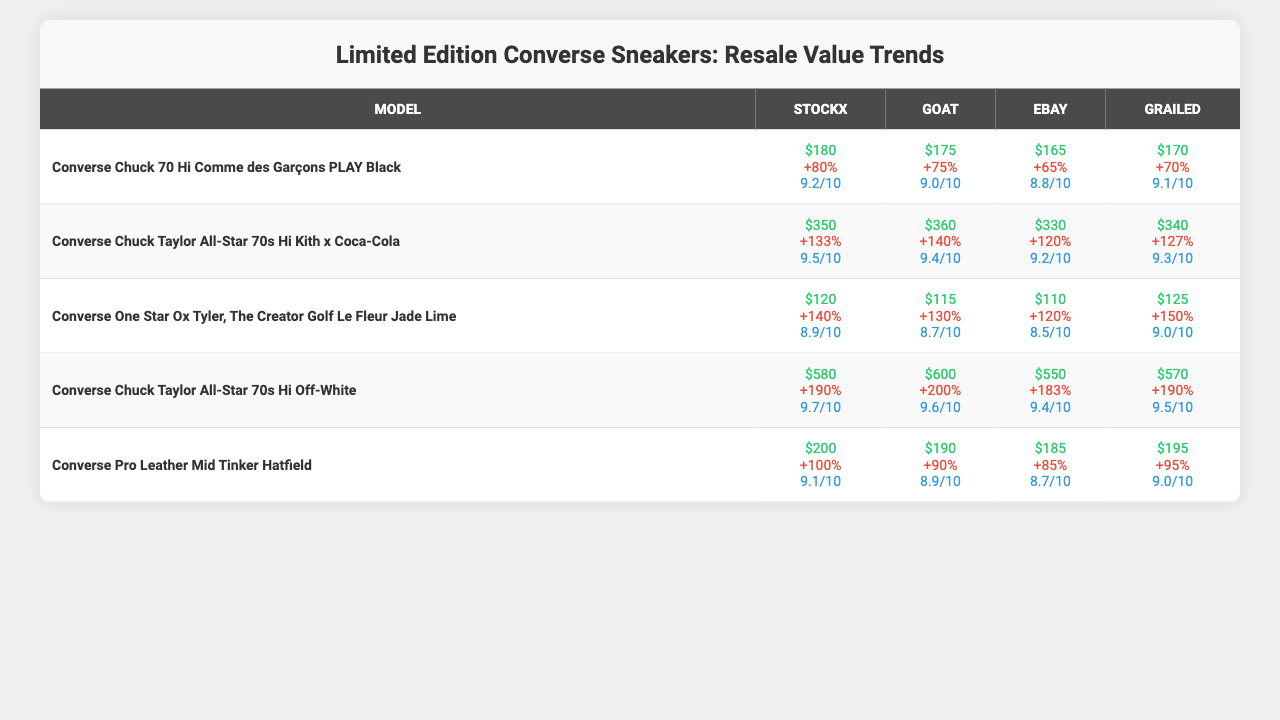What is the highest resale value for the Converse Chuck 70 Hi Comme des Garçons PLAY Black? The resale values for the Converse Chuck 70 Hi Comme des Garçons PLAY Black across the marketplaces are $180, $175, $165, and $170. The highest value among these is $180.
Answer: $180 What is the average resale value of the Converse Chuck Taylor All-Star 70s Hi Off-White? The resale values for the Converse Chuck Taylor All-Star 70s Hi Off-White are $580, $600, $550, and $570. To find the average, we sum these values (580 + 600 + 550 + 570) = 2300 and divide by 4, which gives us an average of 2300 / 4 = 575.
Answer: $575 Which marketplace has the lowest average condition rating across all models? The average condition ratings for each marketplace are: StockX (9.12), GOAT (9.12), eBay (8.88), and Grailed (9.04). Comparing these, eBay has the lowest average condition rating at 8.88.
Answer: eBay What is the percentage increase in resale value for the Converse One Star Ox Tyler, The Creator Golf Le Fleur Jade Lime on GOAT compared to StockX? The percentage increase for StockX is 140%, and for GOAT, it is 130%. The increase from StockX to GOAT is 130% - 140% = -10%, indicating a decrease.
Answer: Decrease Which Converse model had the highest percentage increase in resale value on eBay? The percentage increases on eBay are: Converse Chuck 70 Hi Comme des Garçons PLAY Black (65%), Converse Chuck Taylor All-Star 70s Hi Kith x Coca-Cola (120%), Converse One Star Ox Tyler, The Creator Golf Le Fleur Jade Lime (120%), Converse Chuck Taylor All-Star 70s Hi Off-White (183%), and Converse Pro Leather Mid Tinker Hatfield (85%). The highest value on eBay is 183% for the Converse Chuck Taylor All-Star 70s Hi Off-White.
Answer: Converse Chuck Taylor All-Star 70s Hi Off-White What is the condition rating for the Converse Chuck 70 Hi Comme des Garçons PLAY Black on Grailed? The average condition rating for the Converse Chuck 70 Hi Comme des Garçons PLAY Black on Grailed is 9.1.
Answer: 9.1 If we sum the average condition ratings of all models for the GOAT marketplace, what is the result? The average condition ratings for GOAT are: 9.0, 9.4, 8.7, 9.6, and 8.9. Summing these gives us (9.0 + 9.4 + 8.7 + 9.6 + 8.9) = 45.6.
Answer: 45.6 Is the resale value of the Converse Pro Leather Mid Tinker Hatfield higher on GOAT than on StockX? The resale value for Converse Pro Leather Mid Tinker Hatfield is $190 on StockX and $195 on GOAT. Since $195 is greater than $190, the statement is true.
Answer: Yes What model has the largest difference in resale values between StockX and Grailed? The resale values for StockX and Grailed are: Converse Chuck 70 Hi Comme des Garçons PLAY Black ($180 - $170 = $10), Converse Chuck Taylor All-Star 70s Hi Kith x Coca-Cola ($350 - $340 = $10), Converse One Star Ox Tyler, The Creator Golf Le Fleur Jade Lime ($120 - $125 = -$5), Converse Chuck Taylor All-Star 70s Hi Off-White ($580 - $570 = $10), and Converse Pro Leather Mid Tinker Hatfield ($200 - $195 = $5). The largest difference is $10 for multiple models.
Answer: Multiple models What is the average resale value for Converse models across all marketplaces? The average resale values are: Chuck 70 Hi Comme des Garçons PLAY Black ($180), Chuck Taylor All-Star 70s Hi Kith x Coca-Cola ($350), One Star Ox Tyler, The Creator Golf Le Fleur Jade Lime ($120), Chuck Taylor All-Star 70s Hi Off-White ($580), Pro Leather Mid Tinker Hatfield ($200). Summing these gives ($180 + $350 + $120 + $580 + $200) = $1430 and dividing by 5 gives $286.
Answer: $286 